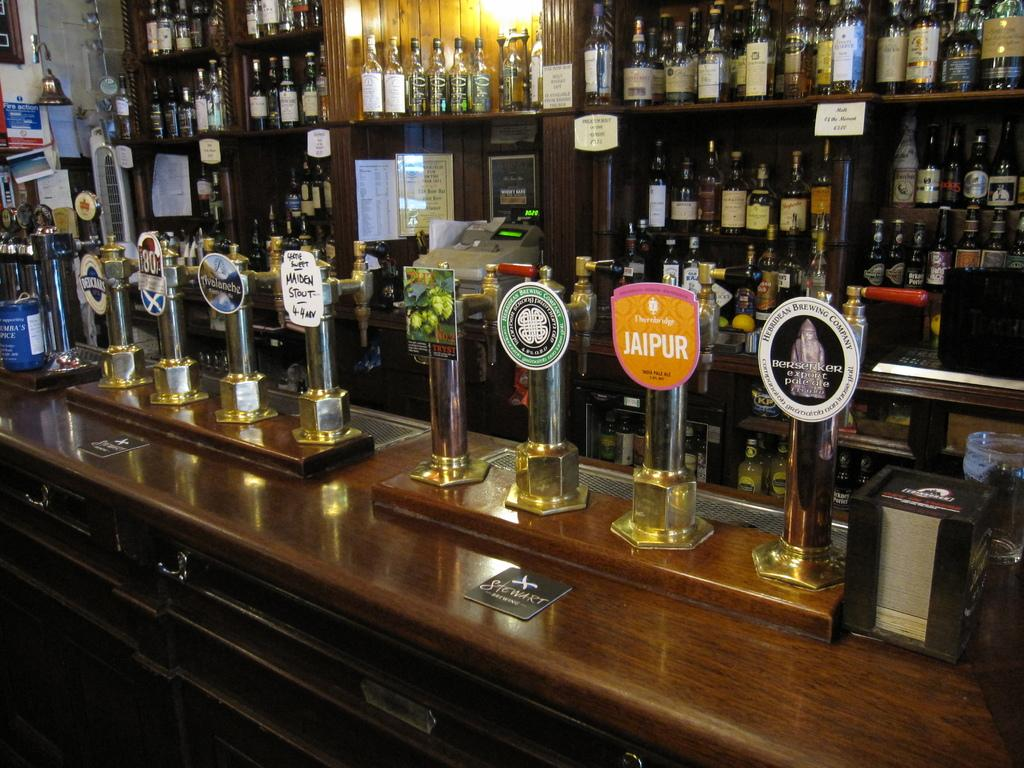What objects are on the table in the image? There are trophies on the table in the image. What can be seen in the background of the image? There are bottles and a machine in the background of the image. What type of substance is the deer consuming from the yak in the image? There is no deer or yak present in the image, so this question cannot be answered. 